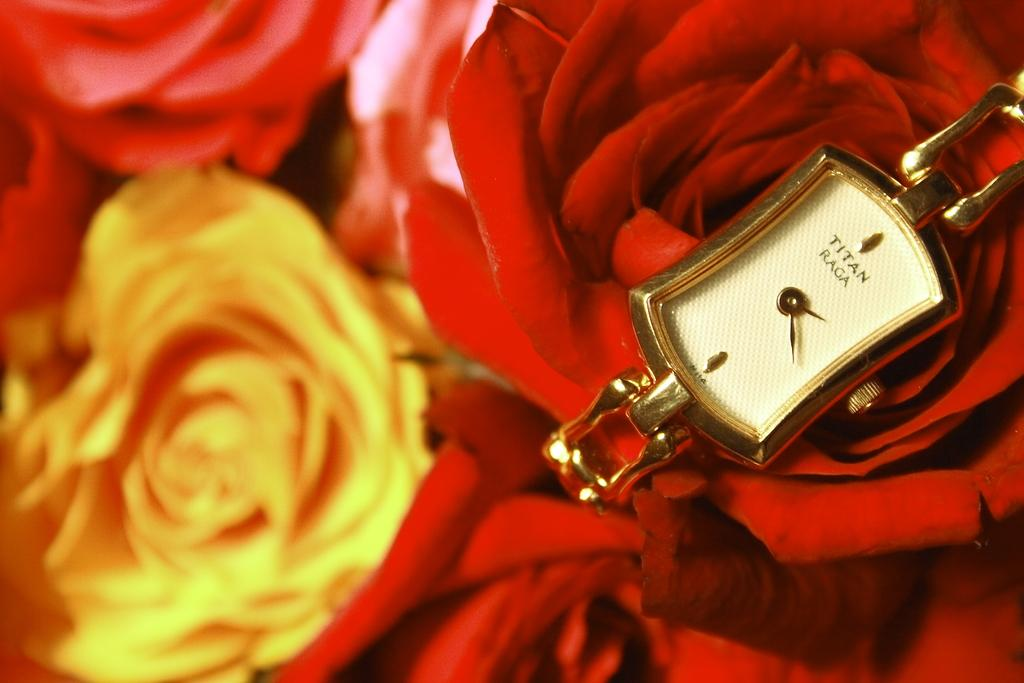Provide a one-sentence caption for the provided image. Face of a watch which says "TITAN" on the front. 